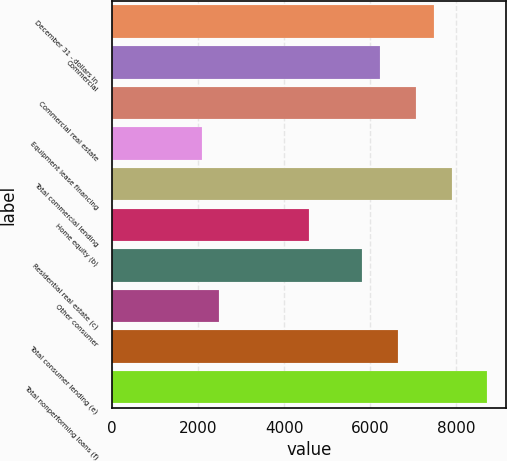Convert chart to OTSL. <chart><loc_0><loc_0><loc_500><loc_500><bar_chart><fcel>December 31 - dollars in<fcel>Commercial<fcel>Commercial real estate<fcel>Equipment lease financing<fcel>Total commercial lending<fcel>Home equity (b)<fcel>Residential real estate (c)<fcel>Other consumer<fcel>Total consumer lending (e)<fcel>Total nonperforming loans (f)<nl><fcel>7479.63<fcel>6233.28<fcel>7064.18<fcel>2078.78<fcel>7895.08<fcel>4571.48<fcel>5817.83<fcel>2494.23<fcel>6648.73<fcel>8725.98<nl></chart> 